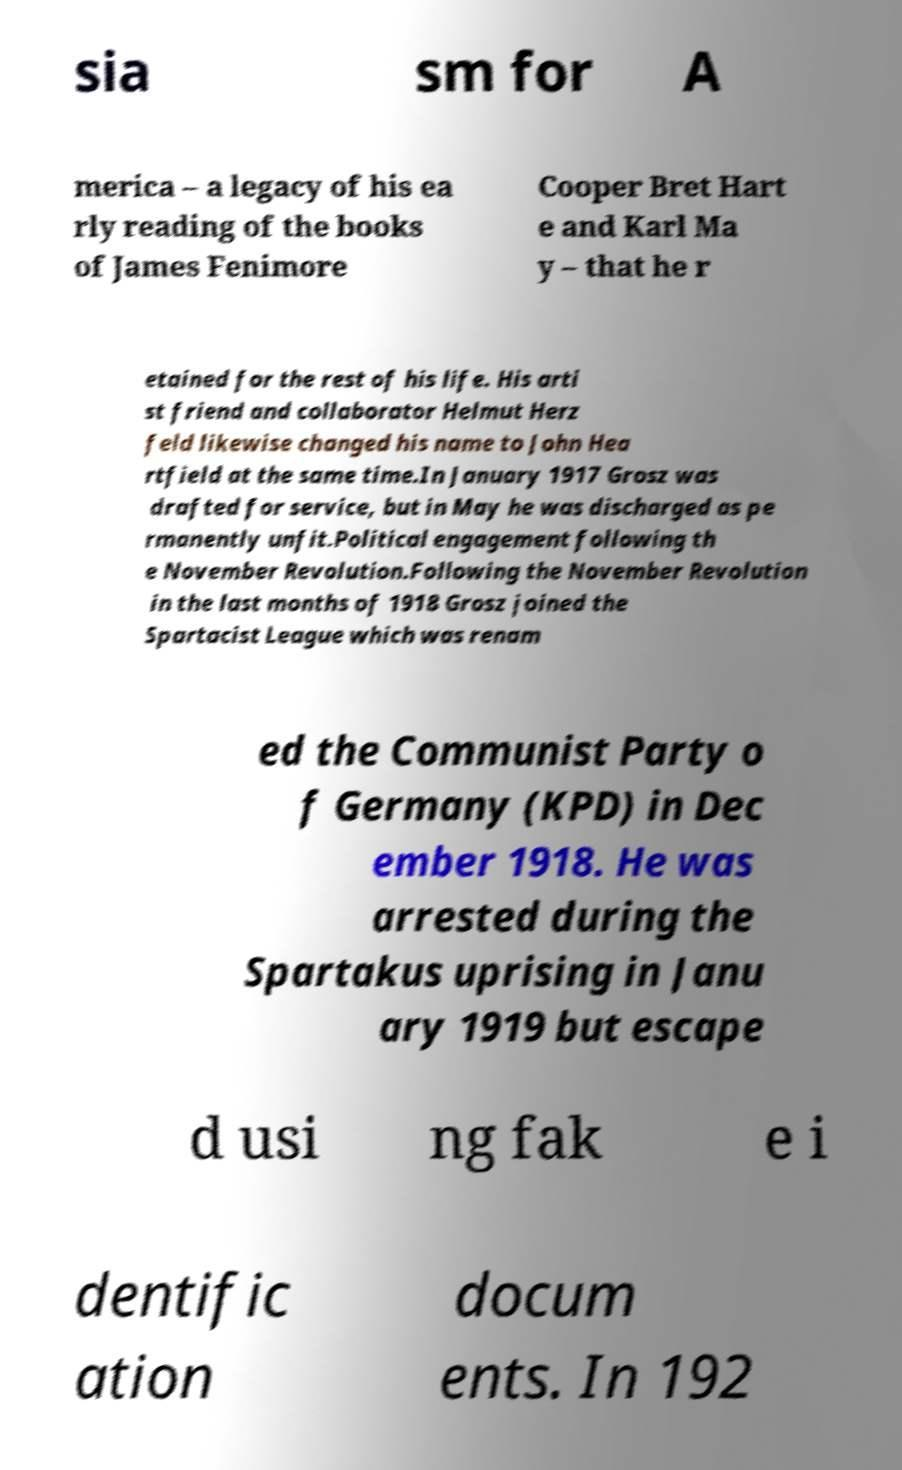Please identify and transcribe the text found in this image. sia sm for A merica – a legacy of his ea rly reading of the books of James Fenimore Cooper Bret Hart e and Karl Ma y – that he r etained for the rest of his life. His arti st friend and collaborator Helmut Herz feld likewise changed his name to John Hea rtfield at the same time.In January 1917 Grosz was drafted for service, but in May he was discharged as pe rmanently unfit.Political engagement following th e November Revolution.Following the November Revolution in the last months of 1918 Grosz joined the Spartacist League which was renam ed the Communist Party o f Germany (KPD) in Dec ember 1918. He was arrested during the Spartakus uprising in Janu ary 1919 but escape d usi ng fak e i dentific ation docum ents. In 192 